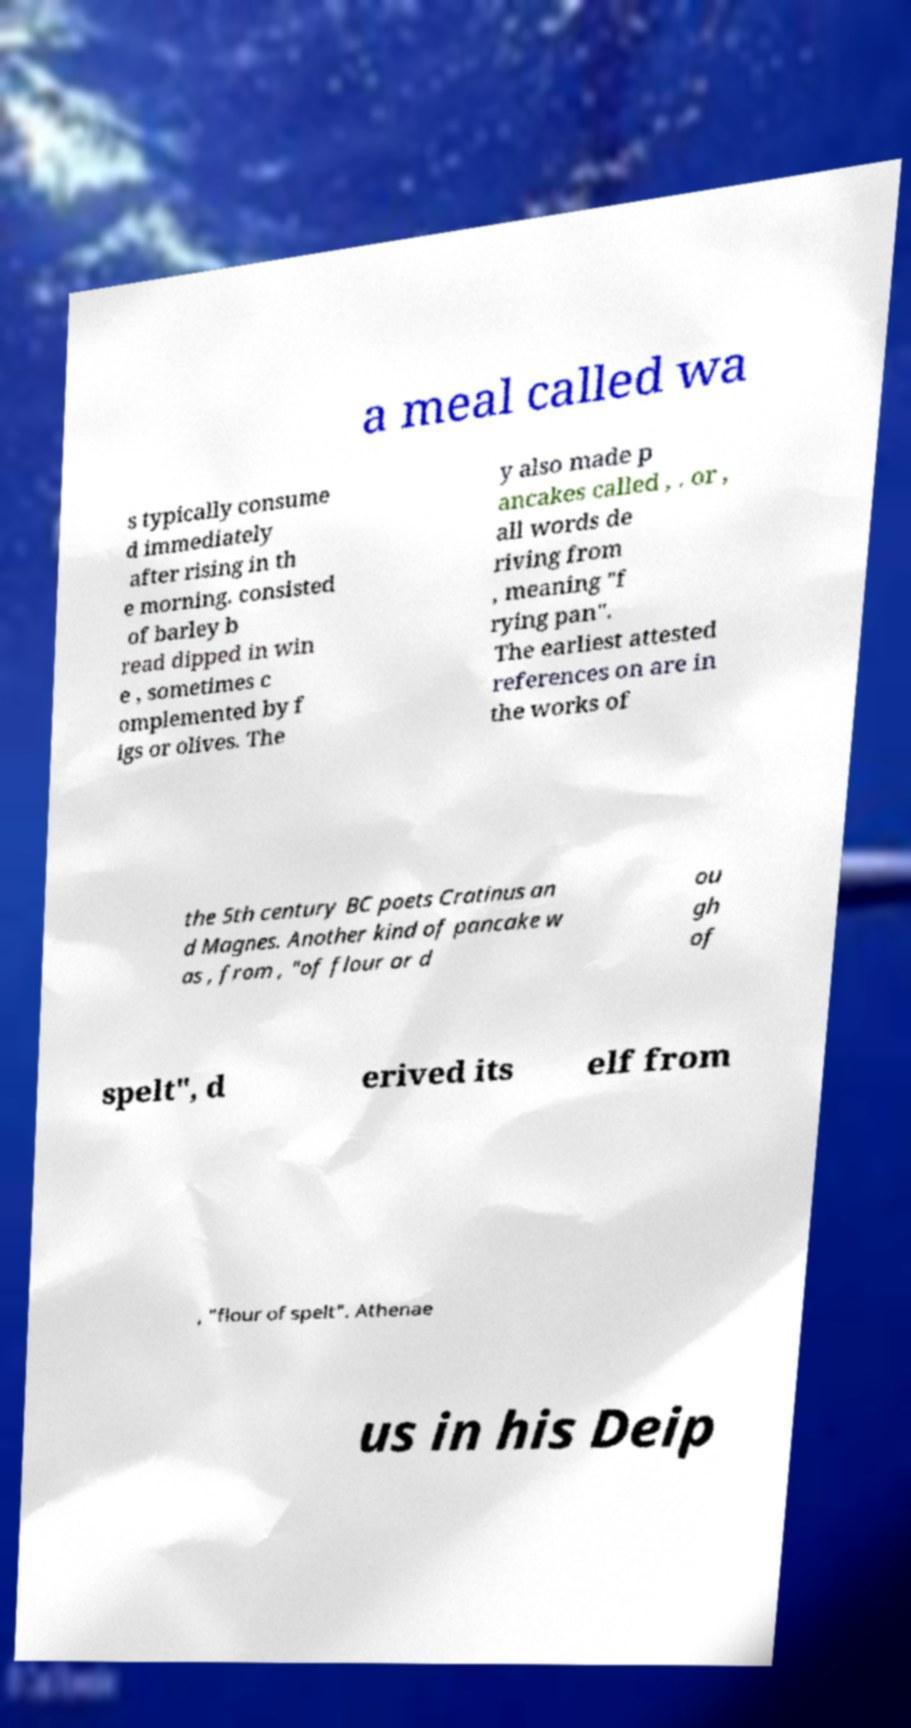There's text embedded in this image that I need extracted. Can you transcribe it verbatim? a meal called wa s typically consume d immediately after rising in th e morning. consisted of barley b read dipped in win e , sometimes c omplemented by f igs or olives. The y also made p ancakes called , . or , all words de riving from , meaning "f rying pan". The earliest attested references on are in the works of the 5th century BC poets Cratinus an d Magnes. Another kind of pancake w as , from , "of flour or d ou gh of spelt", d erived its elf from , "flour of spelt". Athenae us in his Deip 